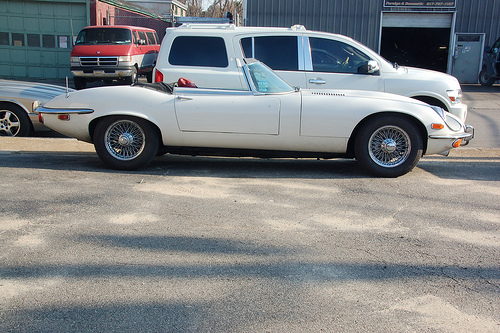<image>
Is there a truck behind the car? Yes. From this viewpoint, the truck is positioned behind the car, with the car partially or fully occluding the truck. Is the car behind the road? No. The car is not behind the road. From this viewpoint, the car appears to be positioned elsewhere in the scene. 